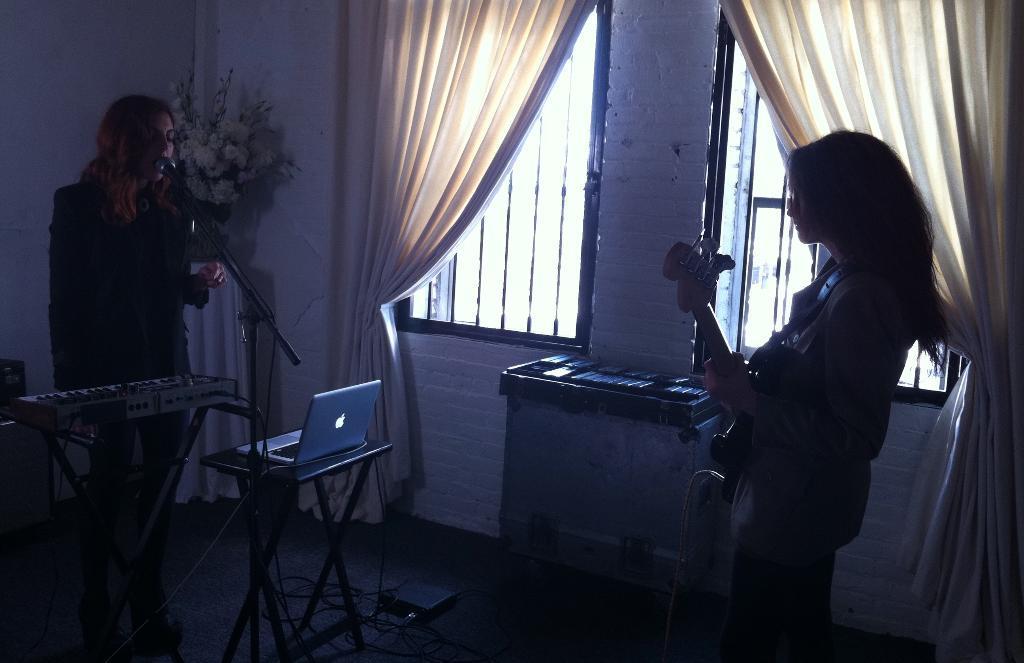Could you give a brief overview of what you see in this image? This image consist of two women. To the left, the woman is singing and playing keyboard. To the right, the woman is playing guitar. In the middle, there is a table on which a laptop is kept. In the background, there is a wall to which there are windows along with curtains. At the bottom, there is a floor. 